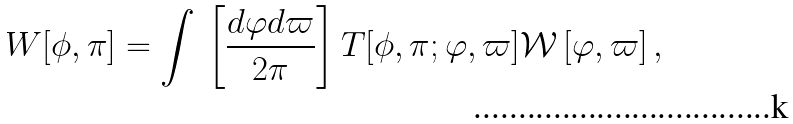Convert formula to latex. <formula><loc_0><loc_0><loc_500><loc_500>W [ \phi , \pi ] = \int \, \left [ \frac { d \varphi d \varpi } { 2 \pi } \right ] T [ \phi , \pi ; \varphi , \varpi ] \mathcal { W } \left [ \varphi , \varpi \right ] ,</formula> 